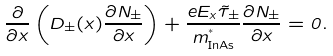Convert formula to latex. <formula><loc_0><loc_0><loc_500><loc_500>\frac { \partial } { \partial x } \left ( D _ { \pm } ( x ) \frac { \partial N _ { \pm } } { \partial x } \right ) + \frac { e E _ { x } \tilde { \tau } _ { \pm } } { m ^ { ^ { * } } _ { \text {InAs} } } \frac { \partial N _ { \pm } } { \partial x } = 0 .</formula> 